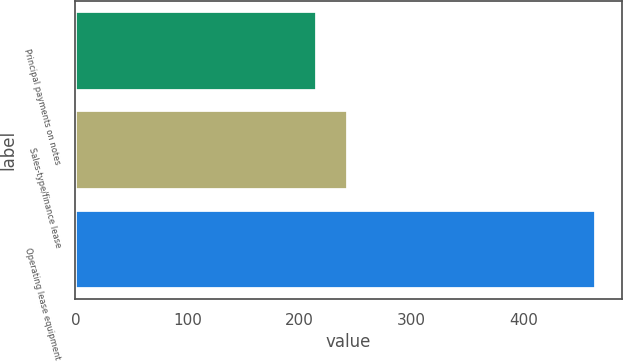Convert chart to OTSL. <chart><loc_0><loc_0><loc_500><loc_500><bar_chart><fcel>Principal payments on notes<fcel>Sales-type/finance lease<fcel>Operating lease equipment<nl><fcel>216<fcel>243<fcel>464<nl></chart> 